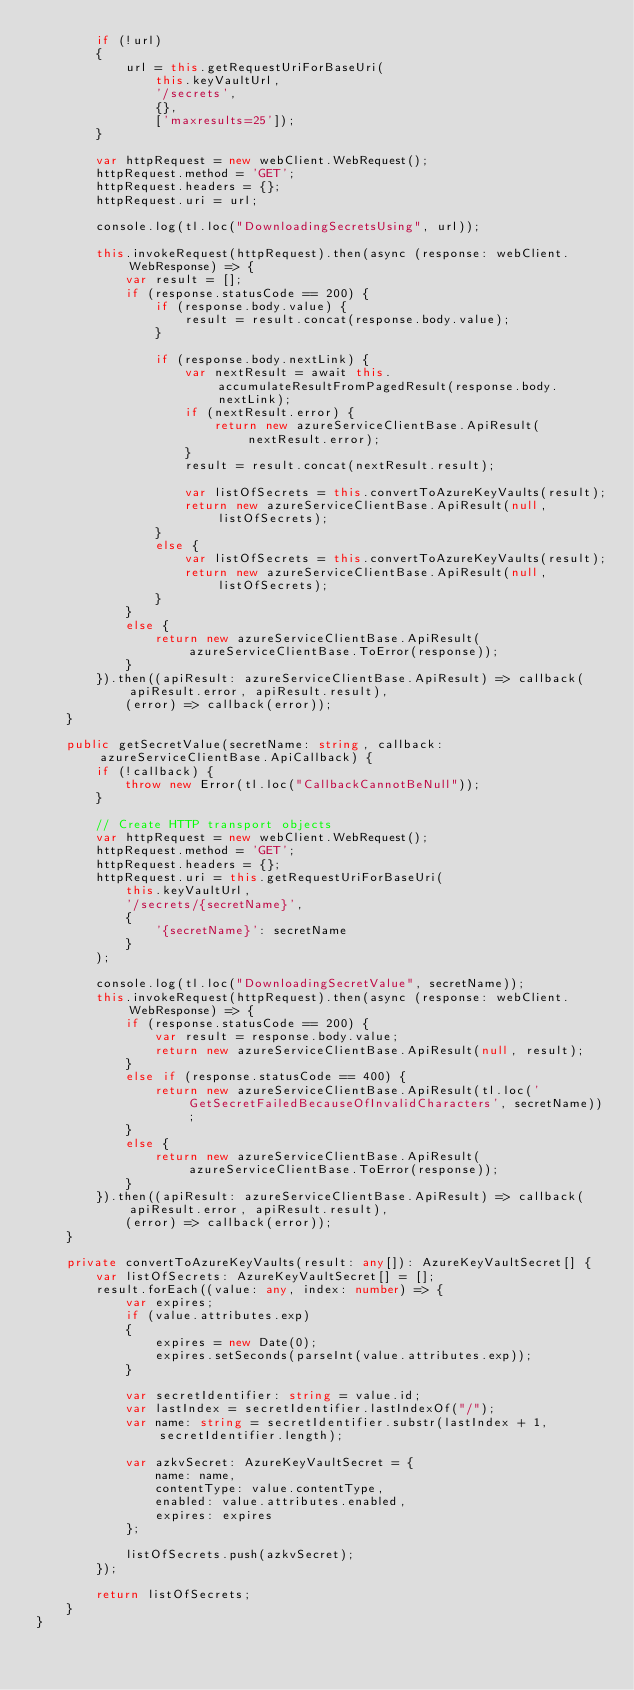<code> <loc_0><loc_0><loc_500><loc_500><_TypeScript_>        if (!url)
        {
            url = this.getRequestUriForBaseUri(
                this.keyVaultUrl,
                '/secrets',
                {},
                ['maxresults=25']);
        }

        var httpRequest = new webClient.WebRequest();
        httpRequest.method = 'GET';
        httpRequest.headers = {};
        httpRequest.uri = url;

        console.log(tl.loc("DownloadingSecretsUsing", url));
        
        this.invokeRequest(httpRequest).then(async (response: webClient.WebResponse) => {
            var result = [];
            if (response.statusCode == 200) {
                if (response.body.value) {
                    result = result.concat(response.body.value);
                }
                
                if (response.body.nextLink) {
                    var nextResult = await this.accumulateResultFromPagedResult(response.body.nextLink);
                    if (nextResult.error) {
                        return new azureServiceClientBase.ApiResult(nextResult.error);
                    }
                    result = result.concat(nextResult.result);

                    var listOfSecrets = this.convertToAzureKeyVaults(result);
                    return new azureServiceClientBase.ApiResult(null, listOfSecrets);
                }
                else {
                    var listOfSecrets = this.convertToAzureKeyVaults(result);
                    return new azureServiceClientBase.ApiResult(null, listOfSecrets);
                }
            }
            else {
                return new azureServiceClientBase.ApiResult(azureServiceClientBase.ToError(response));
            }
        }).then((apiResult: azureServiceClientBase.ApiResult) => callback(apiResult.error, apiResult.result),
            (error) => callback(error));
    }

    public getSecretValue(secretName: string, callback: azureServiceClientBase.ApiCallback) {
        if (!callback) {
            throw new Error(tl.loc("CallbackCannotBeNull"));
        }

        // Create HTTP transport objects
        var httpRequest = new webClient.WebRequest();
        httpRequest.method = 'GET';
        httpRequest.headers = {};
        httpRequest.uri = this.getRequestUriForBaseUri(
            this.keyVaultUrl,
            '/secrets/{secretName}',
            {
                '{secretName}': secretName
            }
        );

        console.log(tl.loc("DownloadingSecretValue", secretName));
        this.invokeRequest(httpRequest).then(async (response: webClient.WebResponse) => {
            if (response.statusCode == 200) {
                var result = response.body.value;
                return new azureServiceClientBase.ApiResult(null, result);
            }
            else if (response.statusCode == 400) {
                return new azureServiceClientBase.ApiResult(tl.loc('GetSecretFailedBecauseOfInvalidCharacters', secretName));
            }
            else {
                return new azureServiceClientBase.ApiResult(azureServiceClientBase.ToError(response));
            }
        }).then((apiResult: azureServiceClientBase.ApiResult) => callback(apiResult.error, apiResult.result),
            (error) => callback(error));
    }

    private convertToAzureKeyVaults(result: any[]): AzureKeyVaultSecret[] {
        var listOfSecrets: AzureKeyVaultSecret[] = [];
        result.forEach((value: any, index: number) => {
            var expires;
            if (value.attributes.exp)
            {
                expires = new Date(0);
                expires.setSeconds(parseInt(value.attributes.exp));
            }

            var secretIdentifier: string = value.id;
            var lastIndex = secretIdentifier.lastIndexOf("/");
            var name: string = secretIdentifier.substr(lastIndex + 1, secretIdentifier.length);

            var azkvSecret: AzureKeyVaultSecret = {
                name: name,
                contentType: value.contentType,
                enabled: value.attributes.enabled,
                expires: expires
            };

            listOfSecrets.push(azkvSecret);
        });

        return listOfSecrets;
    }
}</code> 